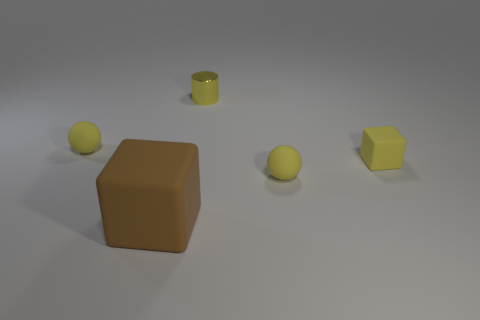Add 1 large blocks. How many objects exist? 6 Subtract all cylinders. How many objects are left? 4 Subtract all small yellow metal cylinders. Subtract all rubber things. How many objects are left? 0 Add 3 metallic cylinders. How many metallic cylinders are left? 4 Add 2 rubber blocks. How many rubber blocks exist? 4 Subtract 0 gray balls. How many objects are left? 5 